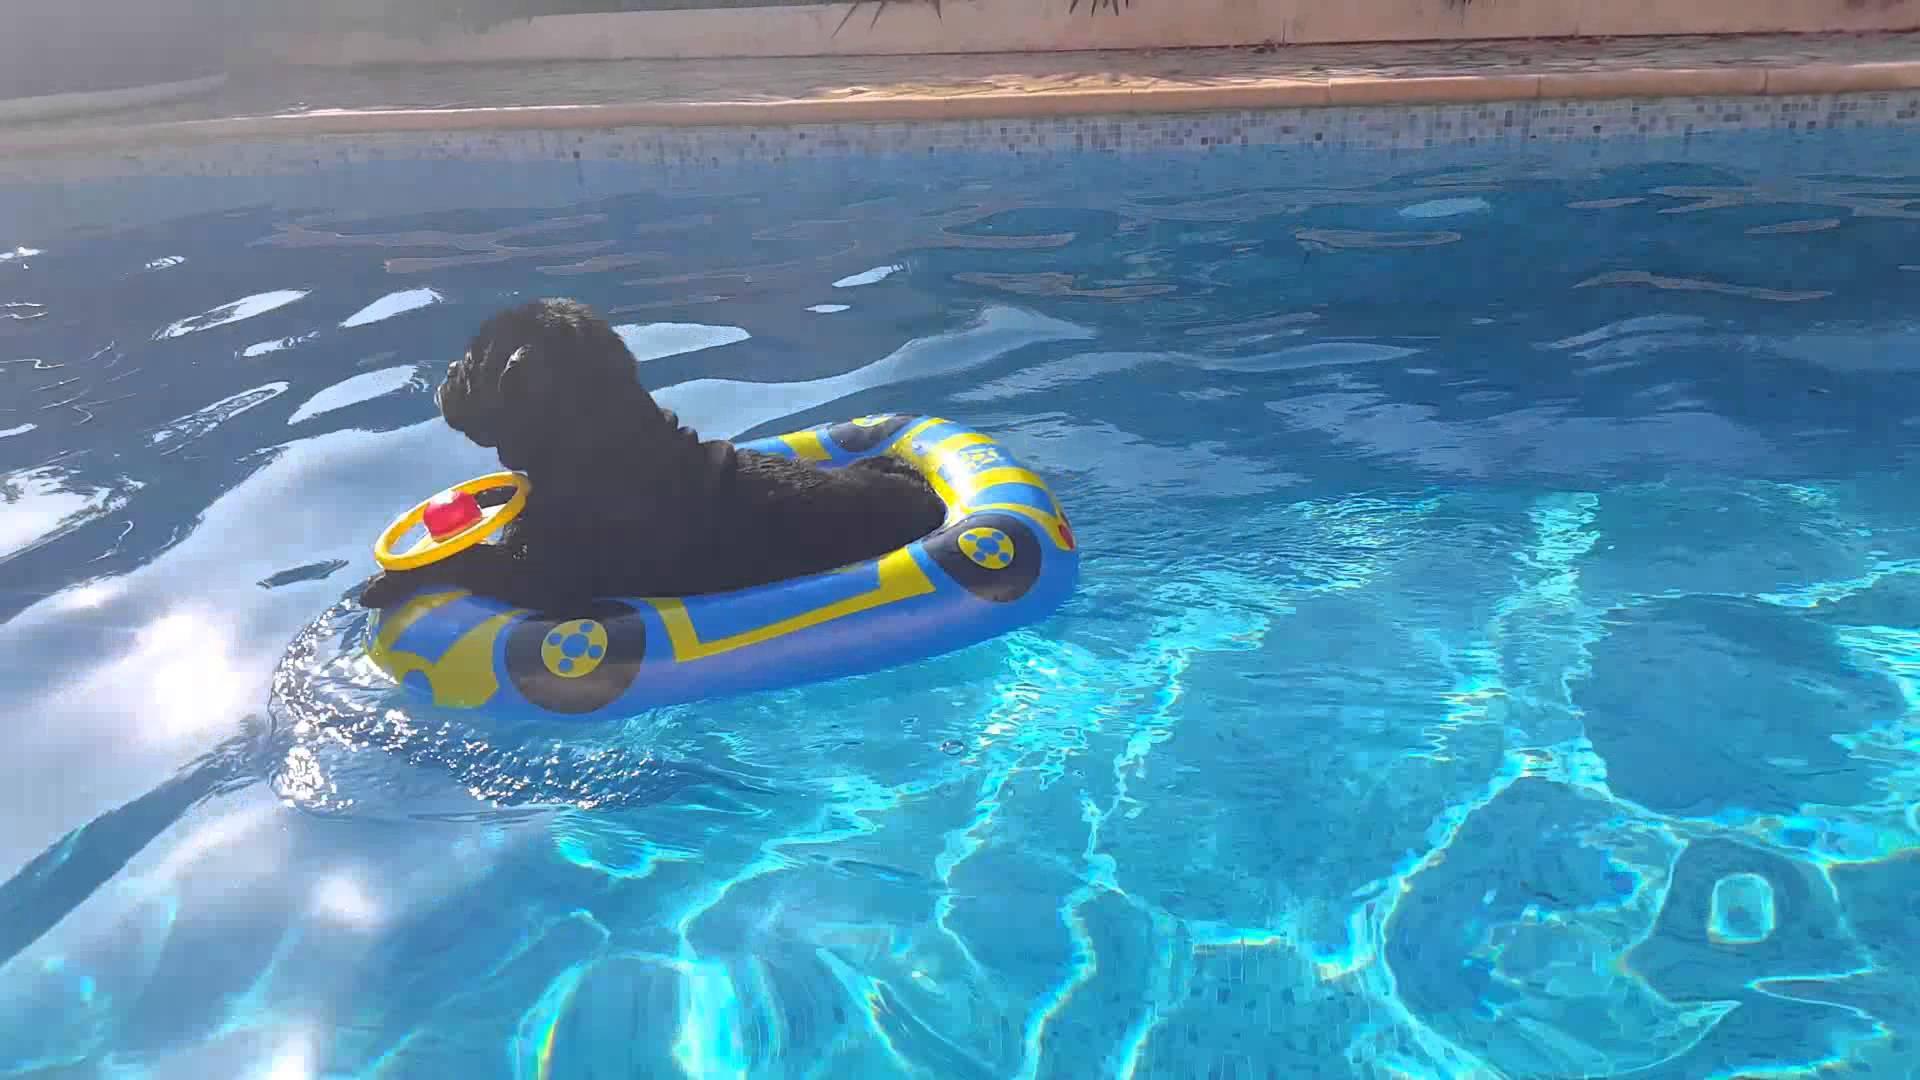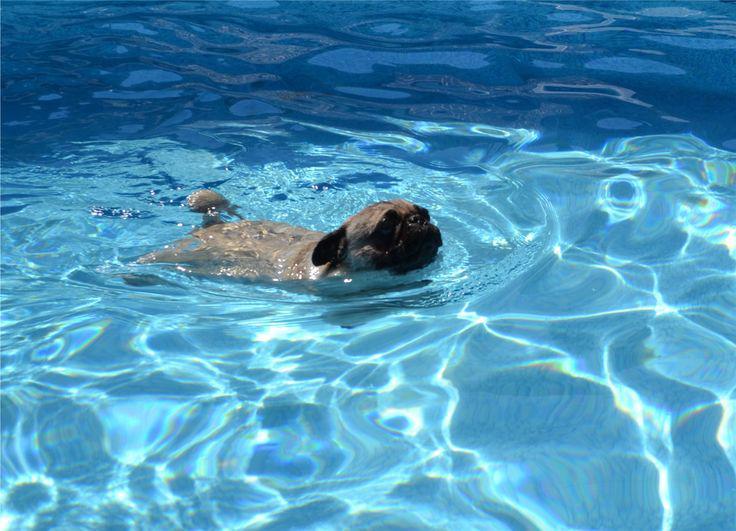The first image is the image on the left, the second image is the image on the right. Examine the images to the left and right. Is the description "Two pug dogs are seen in a swimming pool, one of them riding above the water on an inflatable flotation device, while the other is in the water swimming." accurate? Answer yes or no. Yes. The first image is the image on the left, the second image is the image on the right. Given the left and right images, does the statement "A pug wearing a yellowish life vest swims toward the camera." hold true? Answer yes or no. No. 